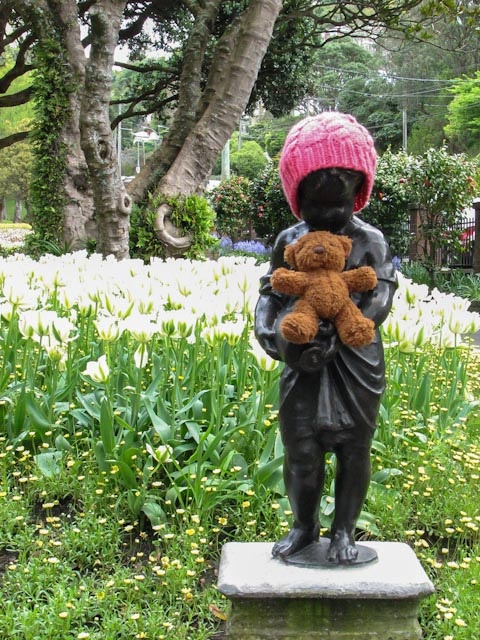Describe the objects in this image and their specific colors. I can see teddy bear in black, brown, maroon, and gray tones and car in black, gray, darkgreen, and darkgray tones in this image. 